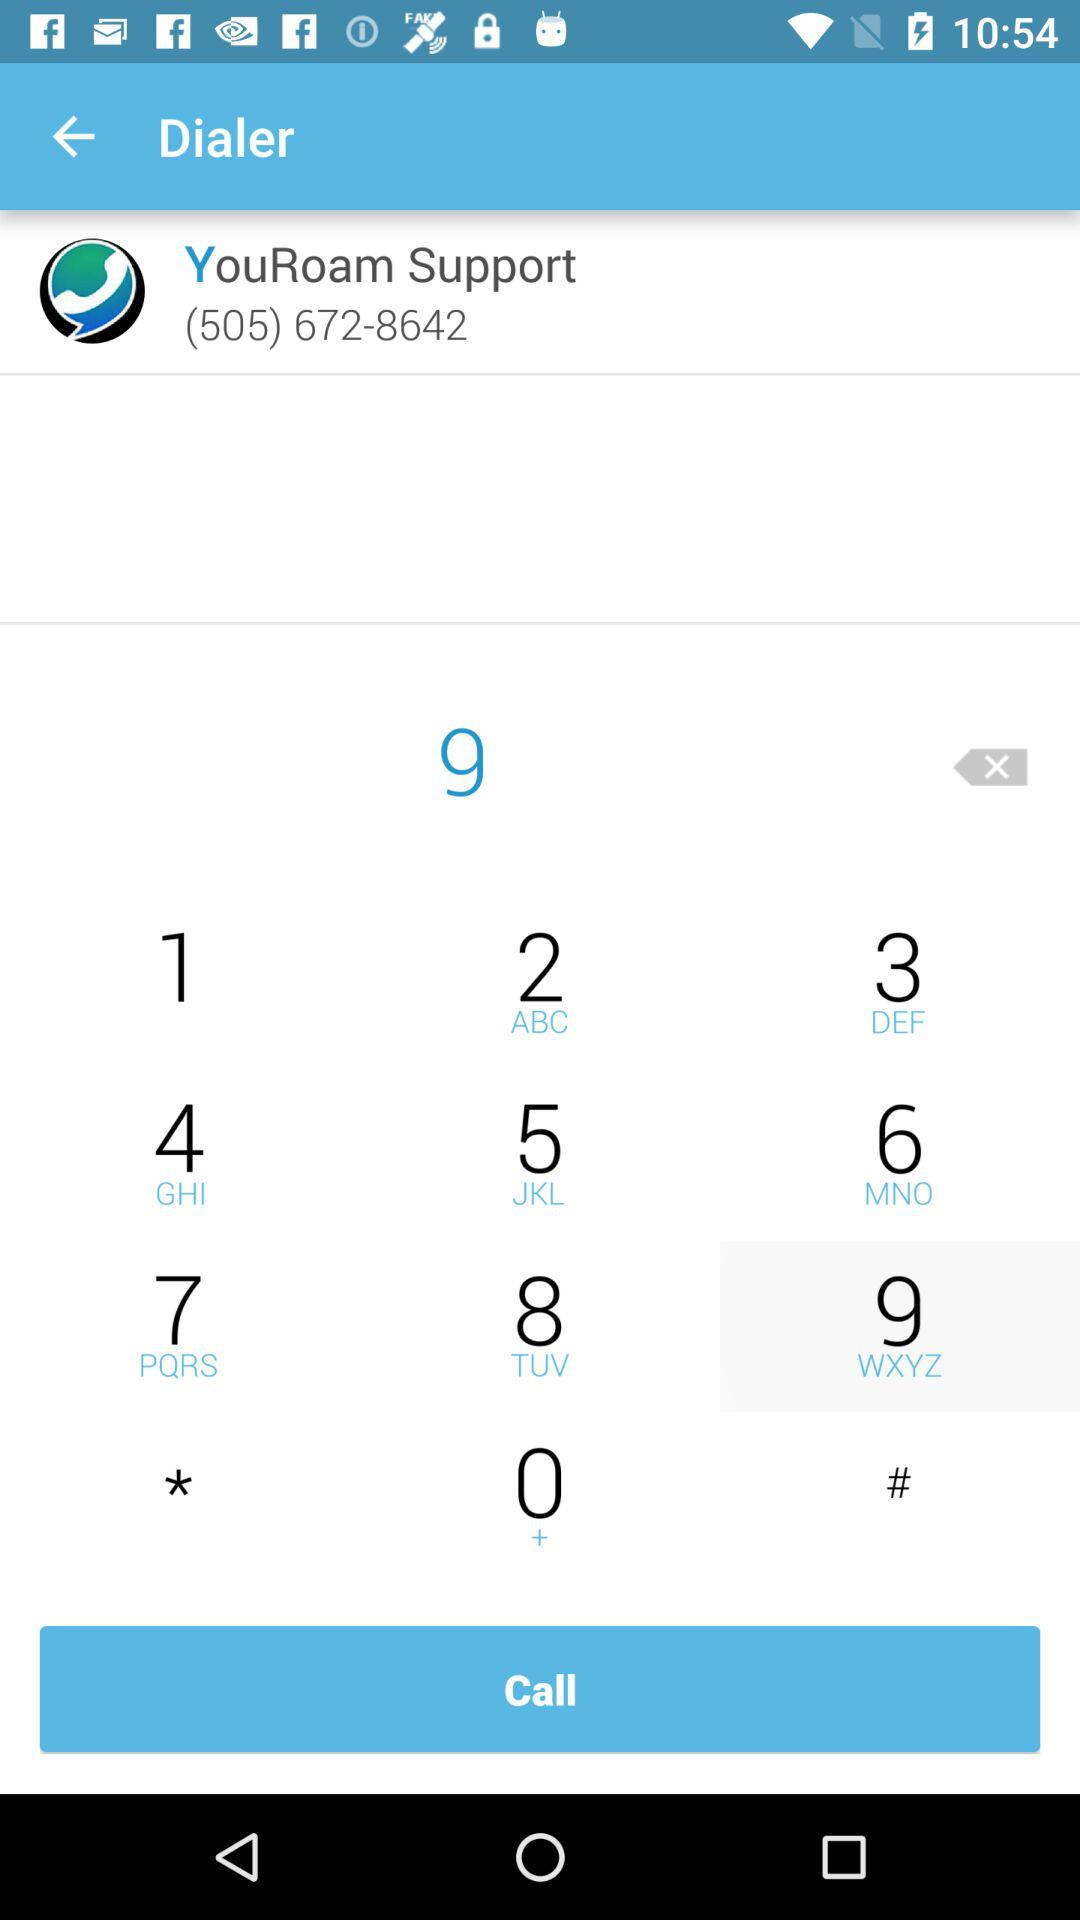What is the contact number for "YouRoam" support? The contact number is (505) 672-8642. 